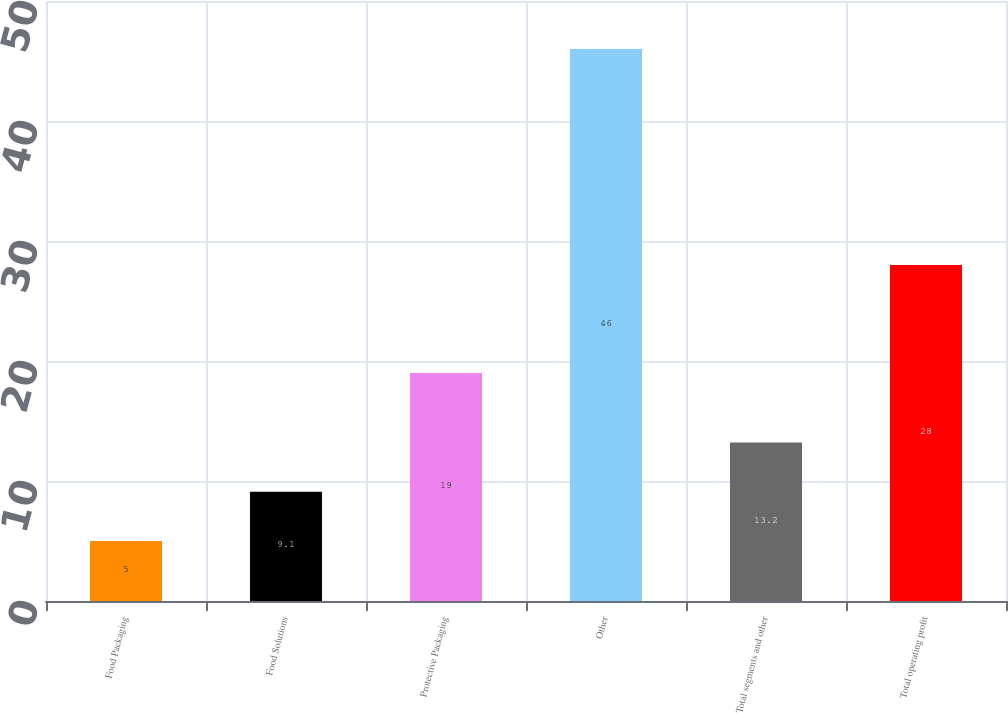Convert chart. <chart><loc_0><loc_0><loc_500><loc_500><bar_chart><fcel>Food Packaging<fcel>Food Solutions<fcel>Protective Packaging<fcel>Other<fcel>Total segments and other<fcel>Total operating profit<nl><fcel>5<fcel>9.1<fcel>19<fcel>46<fcel>13.2<fcel>28<nl></chart> 